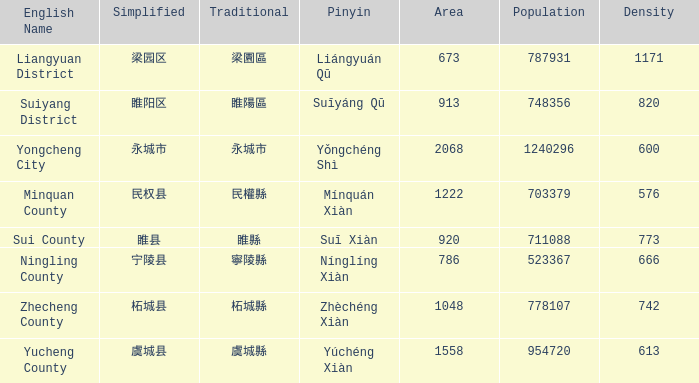What is the traditional form for 宁陵县? 寧陵縣. 